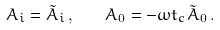Convert formula to latex. <formula><loc_0><loc_0><loc_500><loc_500>A _ { i } = \tilde { A } _ { i } \, , \quad A _ { 0 } = - \omega t _ { c } \tilde { A } _ { 0 } \, .</formula> 